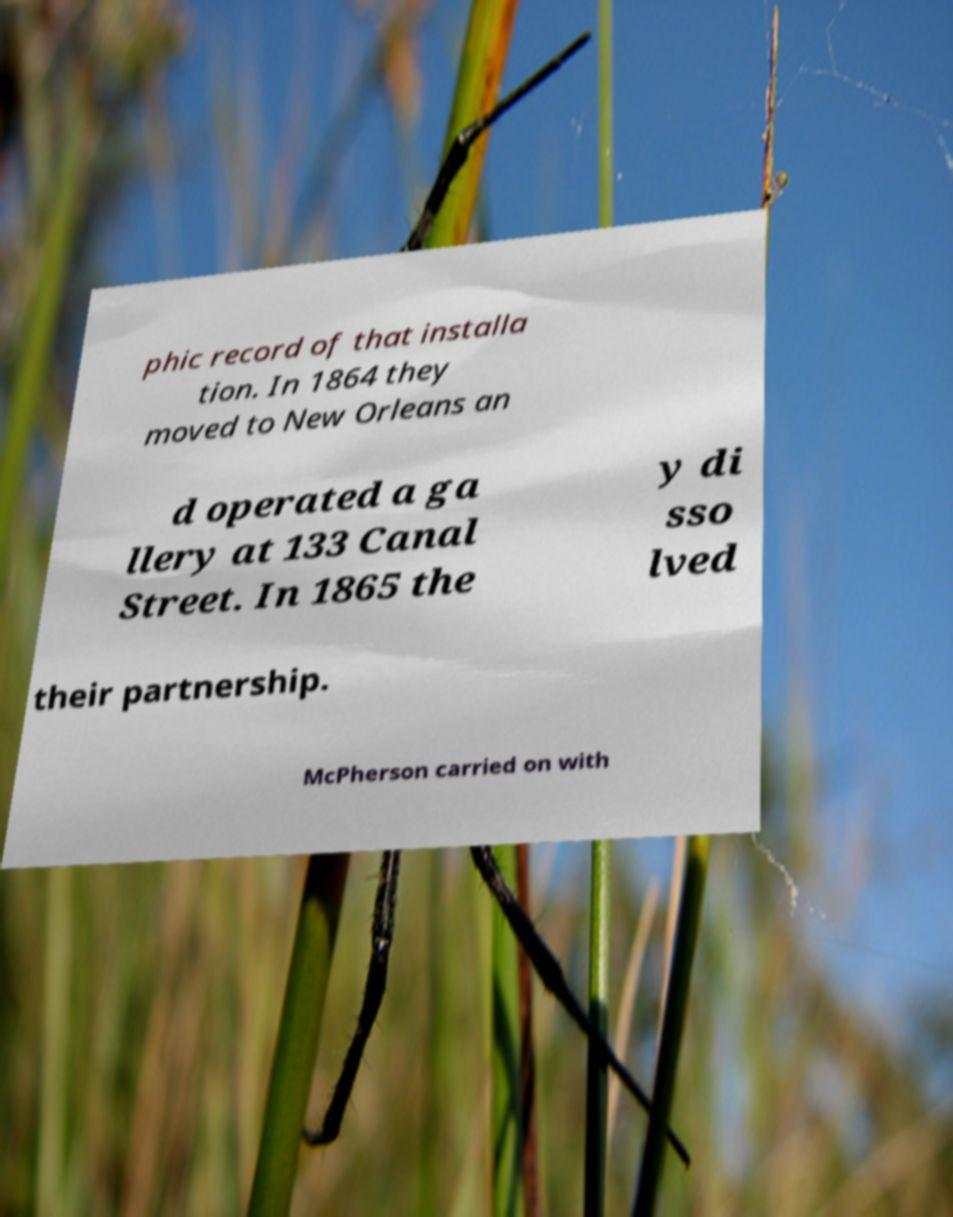What messages or text are displayed in this image? I need them in a readable, typed format. phic record of that installa tion. In 1864 they moved to New Orleans an d operated a ga llery at 133 Canal Street. In 1865 the y di sso lved their partnership. McPherson carried on with 